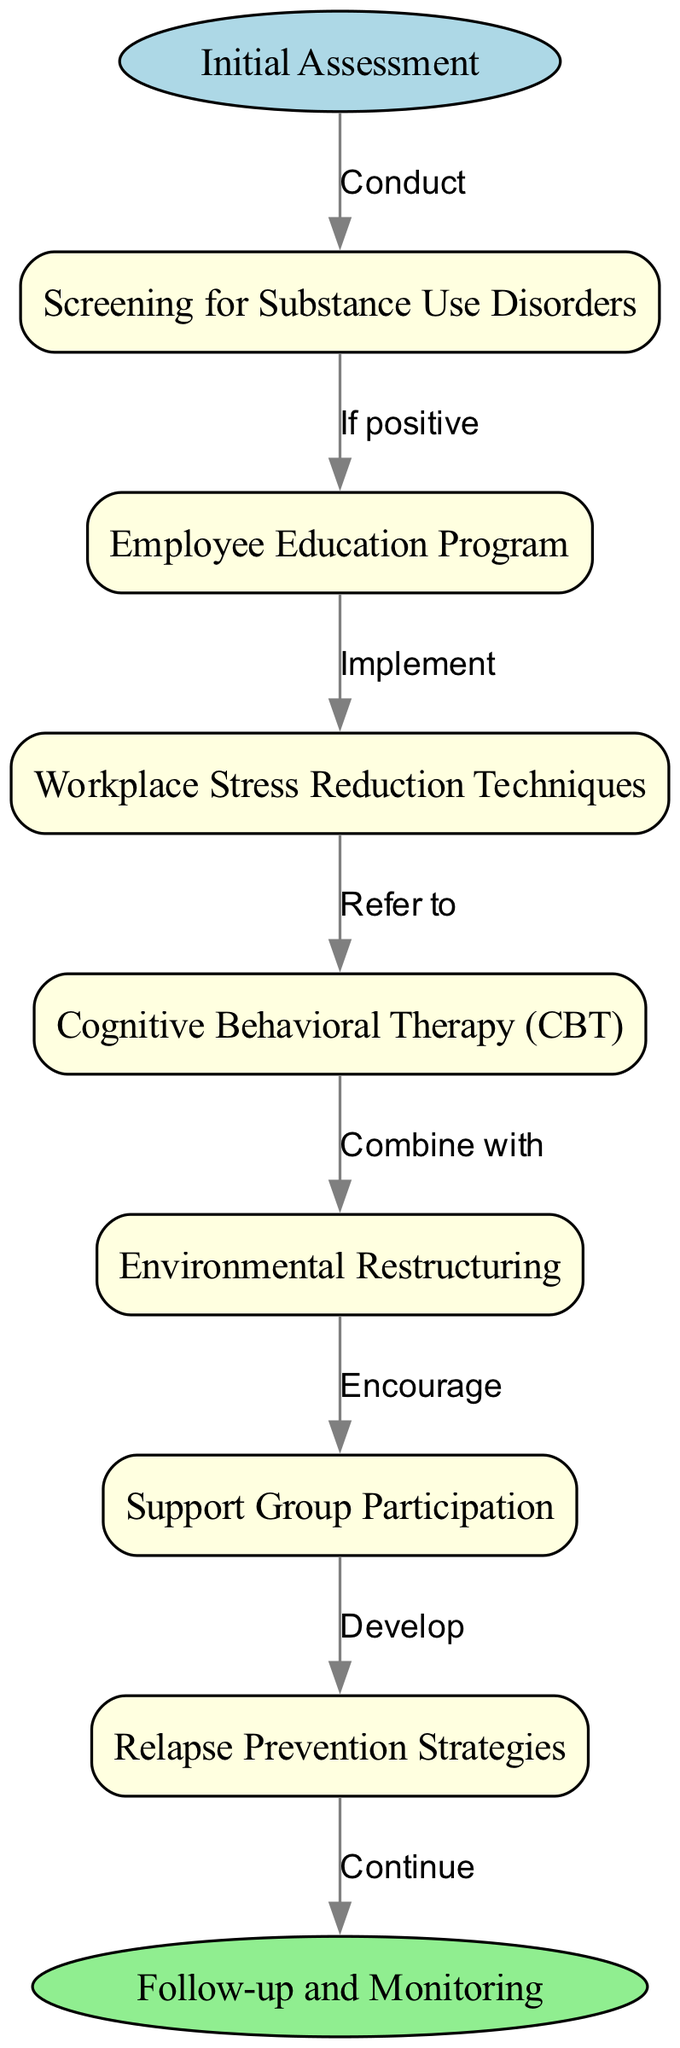What is the starting point of the clinical pathway? The initial node in the diagram represents the starting point, which is explicitly labeled as "Initial Assessment". This node is the first step before any other action is taken in the pathway.
Answer: Initial Assessment How many total nodes are in the diagram? The diagram consists of the start node, end node, and six intermediate nodes related to the clinical pathway, totaling eight nodes. The calculation includes the start and end nodes with the intermediate ones.
Answer: 8 What action is taken after screening for substance use disorders? According to the diagram, if the screening returns a positive result, the next step is to implement an Employee Education Program. This flow is represented by an edge leading to that node.
Answer: Implement Employee Education Program What is combined with cognitive behavioral therapy? The diagram indicates that Cognitive Behavioral Therapy (CBT) is combined with Environmental Restructuring, as seen from the edge connecting these two nodes.
Answer: Environmental Restructuring How many edges are directed towards the end node? There is only one edge that leads directly to the end node "Follow-up and Monitoring," which comes from the last node related to relapse prevention strategies. Only one edge is depicted connecting to this conclusion.
Answer: 1 What is the relationship between Workplace Stress Reduction Techniques and Cognitive Behavioral Therapy? The diagram shows a directional relationship where Workplace Stress Reduction Techniques leads to a referral for Cognitive Behavioral Therapy (CBT). This is established by the edge that connects the two nodes, indicating a referral action.
Answer: Refer to What is the last action taken before ending the pathway? The last action detailed in the pathway is to develop relapse prevention strategies, which leads directly to the end node indicating the conclusion of the clinical pathway. This action precedes the follow-up and monitoring stage.
Answer: Develop Relapse Prevention Strategies Which node has the function of encouraging participation? In the diagram, the node titled "Support Group Participation" has the function of encouraging participation among the employees, as depicted by the edge that connects it from Environmental Restructuring.
Answer: Encourage What node follows the implement action from the Employee Education Program? The flow from the Employee Education Program directly leads to the node representing Workplace Stress Reduction Techniques, indicating that after implementation, this step is taken next in the pathway.
Answer: Workplace Stress Reduction Techniques 